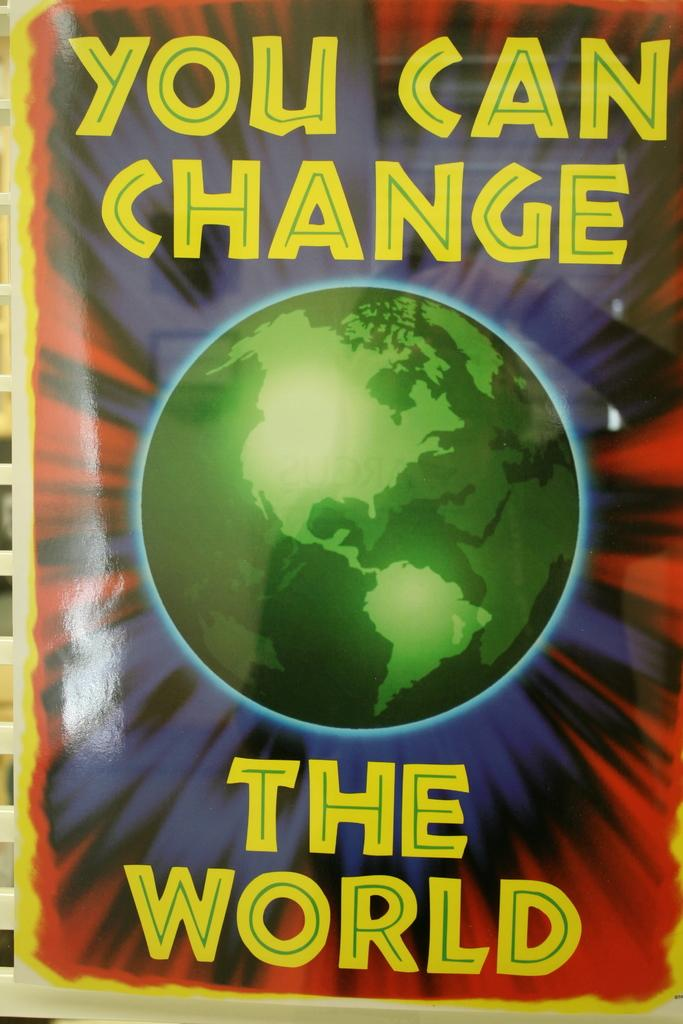<image>
Write a terse but informative summary of the picture. Book cover with a globe and the words you can change the world in yellow lettering. 